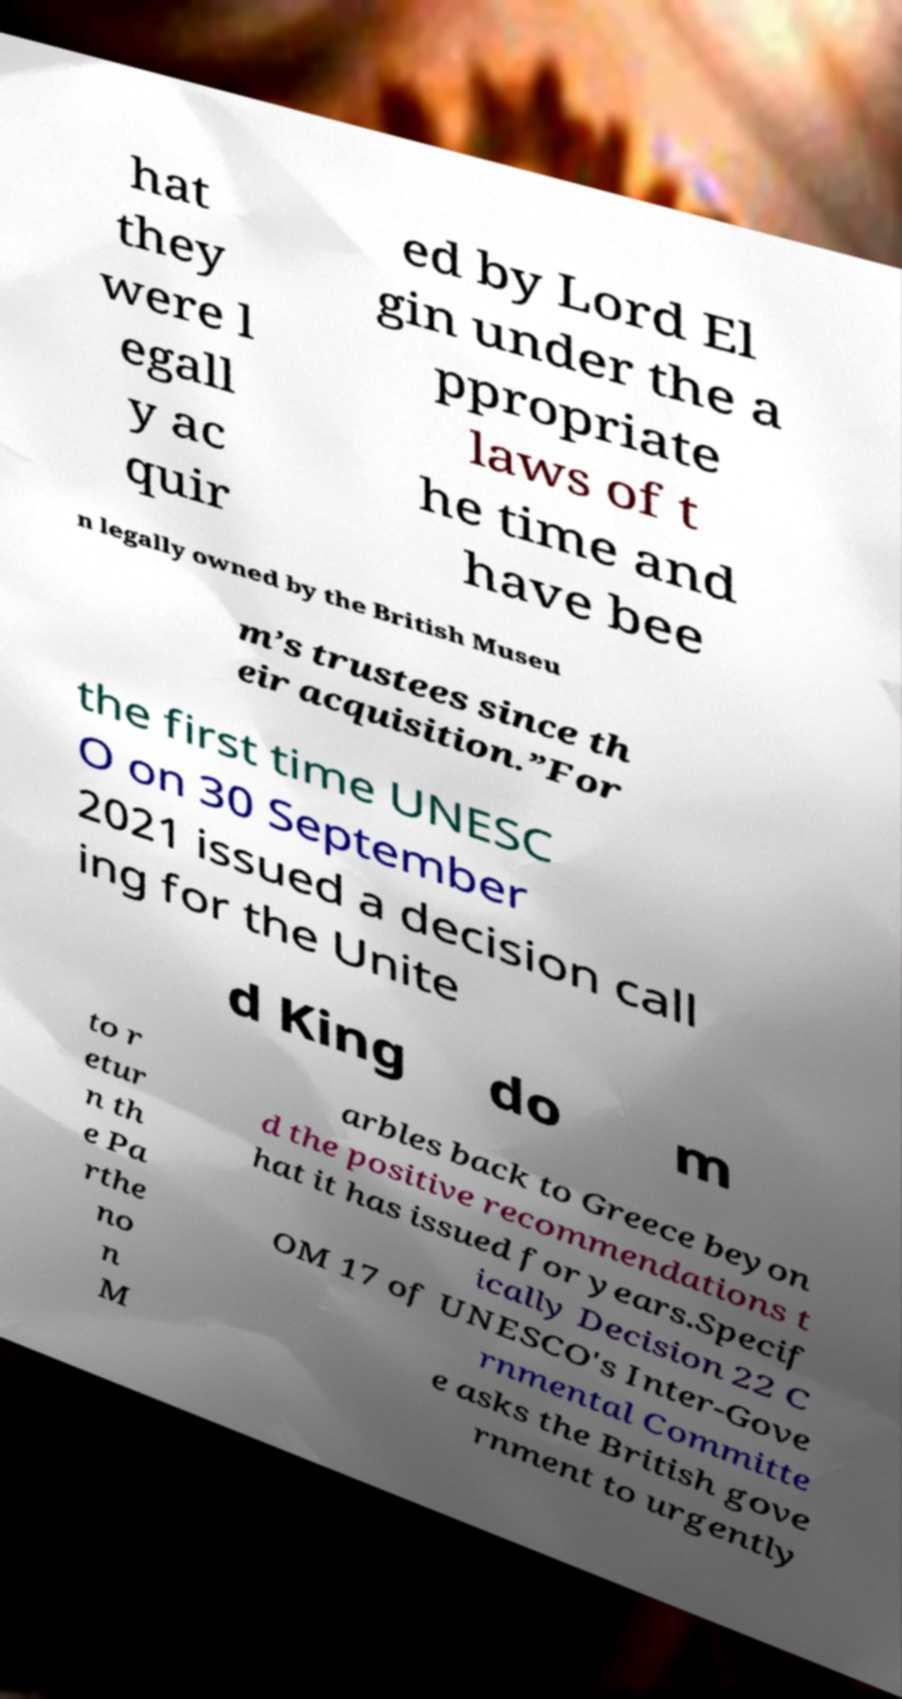Could you assist in decoding the text presented in this image and type it out clearly? hat they were l egall y ac quir ed by Lord El gin under the a ppropriate laws of t he time and have bee n legally owned by the British Museu m’s trustees since th eir acquisition.”For the first time UNESC O on 30 September 2021 issued a decision call ing for the Unite d King do m to r etur n th e Pa rthe no n M arbles back to Greece beyon d the positive recommendations t hat it has issued for years.Specif ically Decision 22 C OM 17 of UNESCO's Inter-Gove rnmental Committe e asks the British gove rnment to urgently 